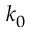Convert formula to latex. <formula><loc_0><loc_0><loc_500><loc_500>k _ { 0 }</formula> 